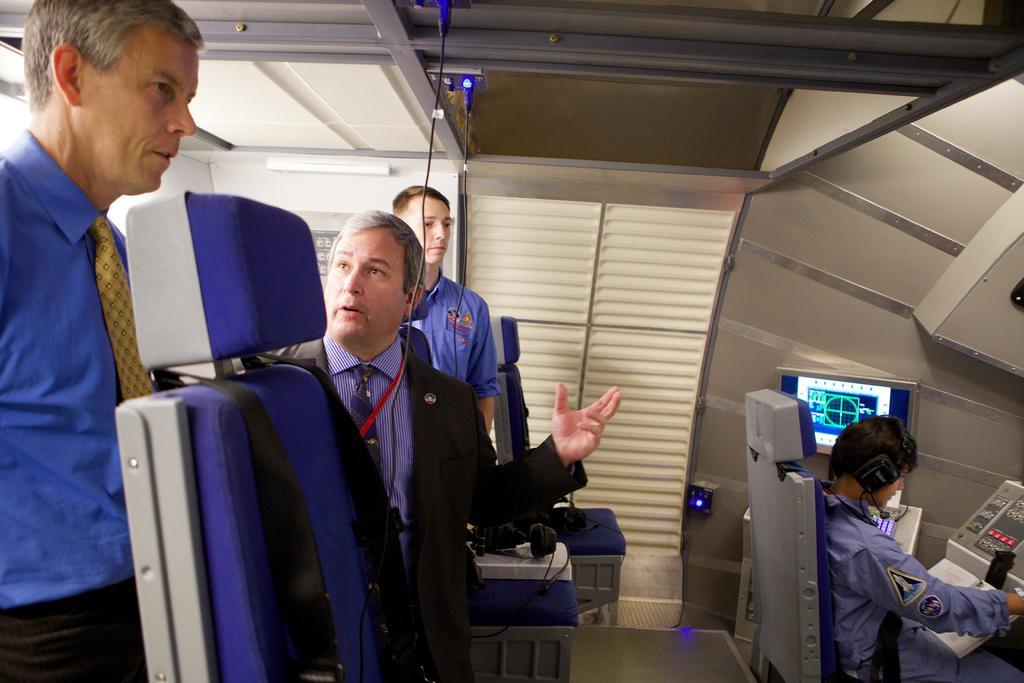Can you describe this image briefly? In this picture we can see 4 people in a cabin with chairs & computer systems. 